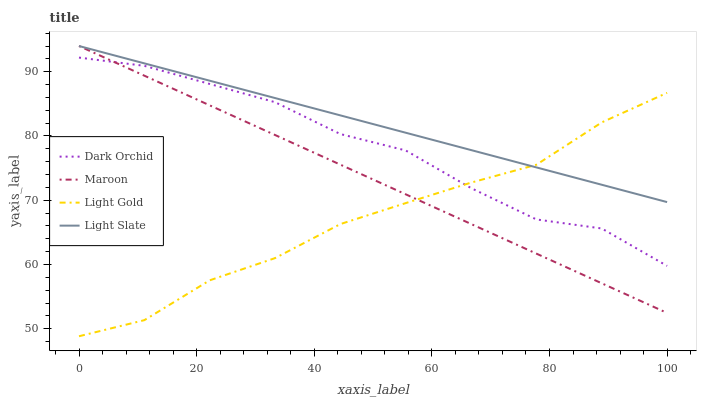Does Light Gold have the minimum area under the curve?
Answer yes or no. Yes. Does Light Slate have the maximum area under the curve?
Answer yes or no. Yes. Does Maroon have the minimum area under the curve?
Answer yes or no. No. Does Maroon have the maximum area under the curve?
Answer yes or no. No. Is Light Slate the smoothest?
Answer yes or no. Yes. Is Dark Orchid the roughest?
Answer yes or no. Yes. Is Light Gold the smoothest?
Answer yes or no. No. Is Light Gold the roughest?
Answer yes or no. No. Does Light Gold have the lowest value?
Answer yes or no. Yes. Does Maroon have the lowest value?
Answer yes or no. No. Does Maroon have the highest value?
Answer yes or no. Yes. Does Light Gold have the highest value?
Answer yes or no. No. Is Dark Orchid less than Light Slate?
Answer yes or no. Yes. Is Light Slate greater than Dark Orchid?
Answer yes or no. Yes. Does Maroon intersect Light Gold?
Answer yes or no. Yes. Is Maroon less than Light Gold?
Answer yes or no. No. Is Maroon greater than Light Gold?
Answer yes or no. No. Does Dark Orchid intersect Light Slate?
Answer yes or no. No. 